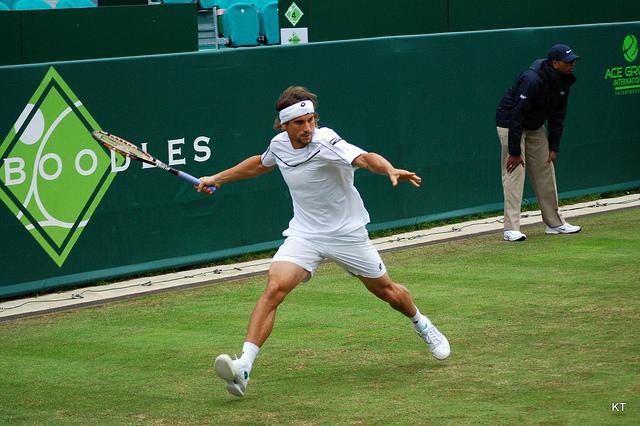Please identify all text content in this image. boodles KT ACE GR 4 